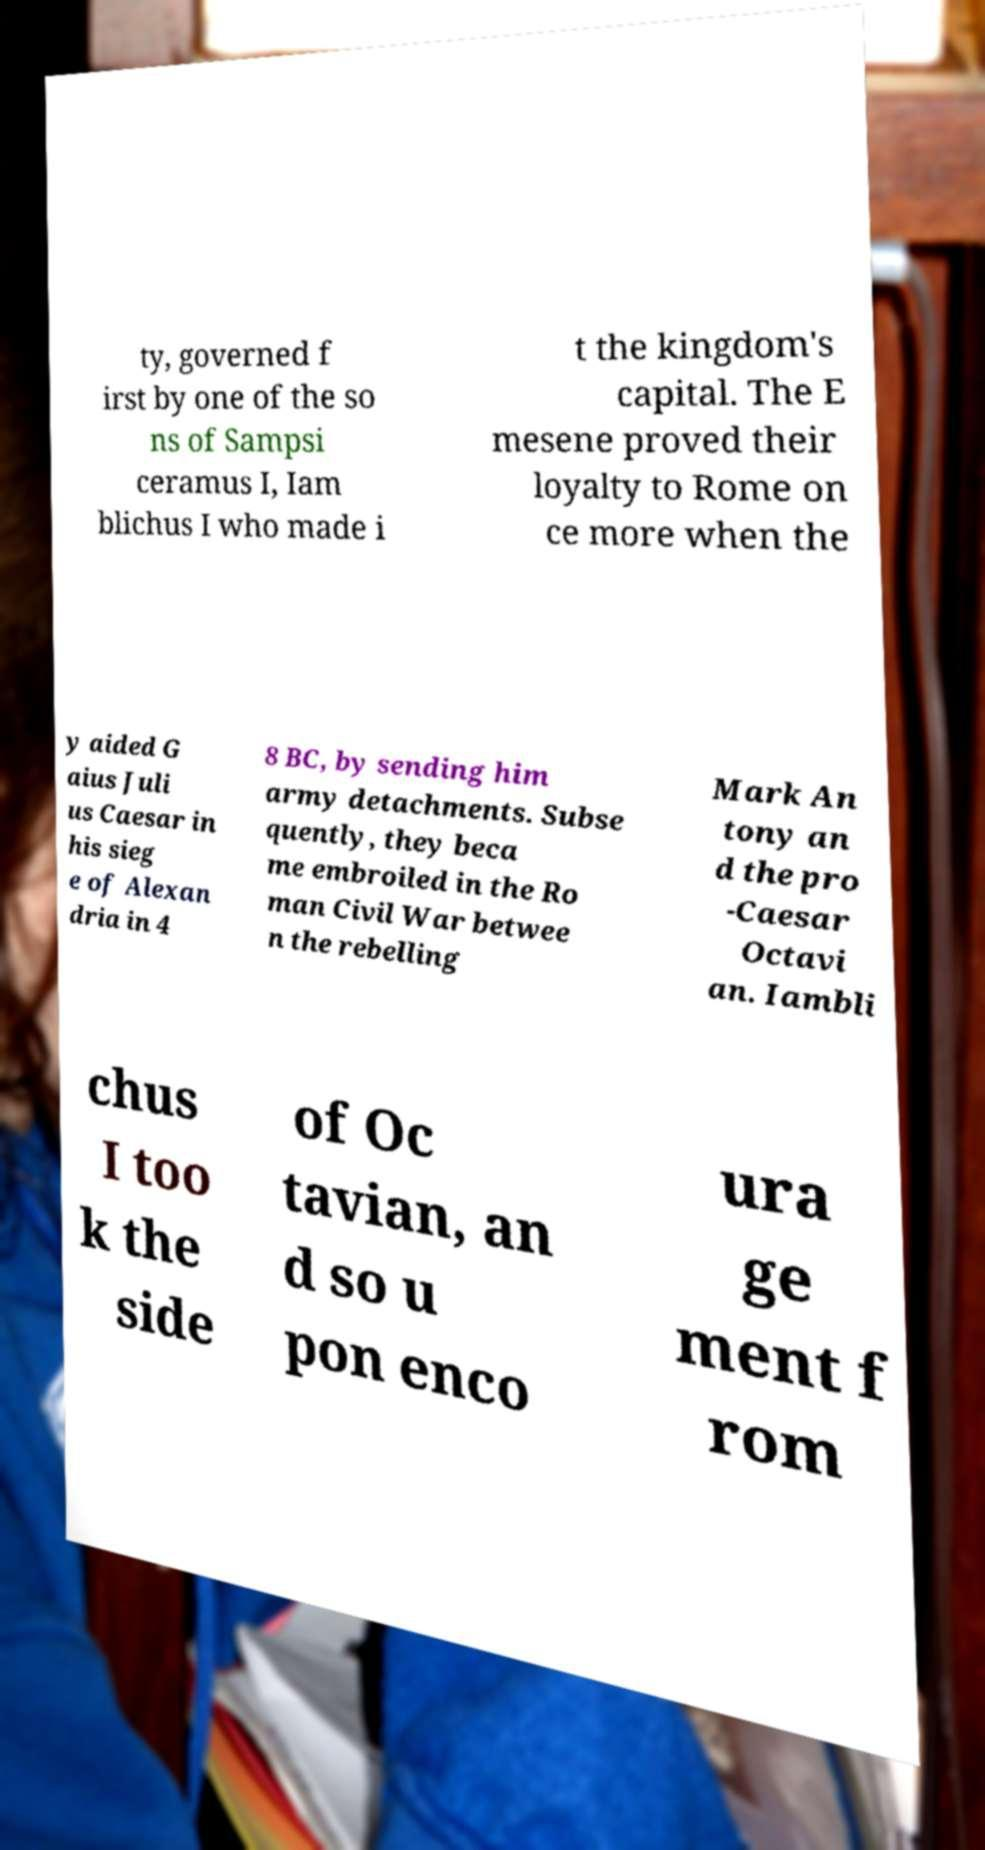There's text embedded in this image that I need extracted. Can you transcribe it verbatim? ty, governed f irst by one of the so ns of Sampsi ceramus I, Iam blichus I who made i t the kingdom's capital. The E mesene proved their loyalty to Rome on ce more when the y aided G aius Juli us Caesar in his sieg e of Alexan dria in 4 8 BC, by sending him army detachments. Subse quently, they beca me embroiled in the Ro man Civil War betwee n the rebelling Mark An tony an d the pro -Caesar Octavi an. Iambli chus I too k the side of Oc tavian, an d so u pon enco ura ge ment f rom 